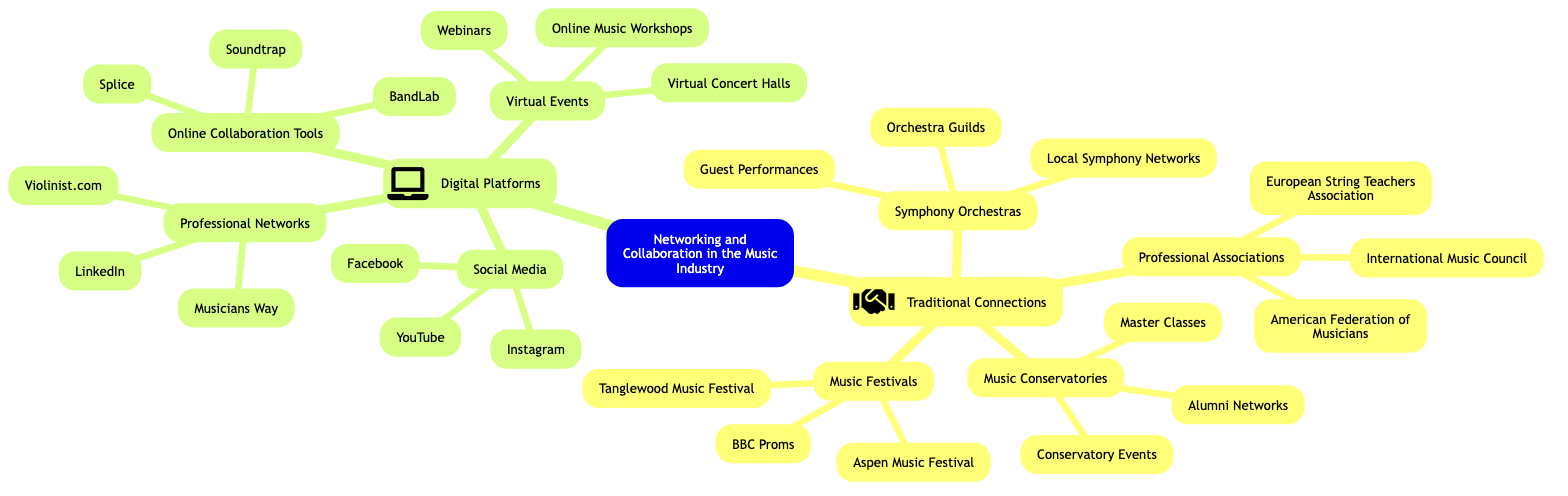What are the four main subtopics in the diagram? The diagram branches into two main categories: Traditional Connections and Digital Platforms. Under each category, there are more subtopics. Counting these, we see there are four subtopics under Traditional Connections (Symphony Orchestras, Music Conservatories, Professional Associations, Music Festivals) and four under Digital Platforms (Social Media, Professional Networks, Online Collaboration Tools, Virtual Events), making a total of eight.
Answer: eight Which branch includes Alumni Networks? Alumni Networks is specifically listed under the branch of Music Conservatories. By checking the subtopic "Traditional Connections," I find that Alumni Networks is one of its elements.
Answer: Music Conservatories What is one example of a Virtual Event? Referring to the subtopic “Virtual Events” under Digital Platforms, we find multiple elements listed, one being "Webinars." This can be directly identified as an example of a Virtual Event in the diagram.
Answer: Webinars How many elements are listed under Online Collaboration Tools? Under the branch "Online Collaboration Tools," there are three elements stated: "Soundtrap," "Splice," and "BandLab." By counting these elements listed, we find that there are three total.
Answer: three Which type of connection is represented by the American Federation of Musicians? The American Federation of Musicians is categorized under Professional Associations, which is part of the Traditional Connections subtopic. It indicates a form of professional networking that is traditional in the music industry.
Answer: Professional Associations What digital platform is focused on professional networking? The Professional Networks subtopic specifically addresses digital platforms aimed at professional connections. The diagram mentions LinkedIn, Violinist.com, and Musicians Way as examples of this type of platform. Hence, one of them would be sufficient as an answer.
Answer: LinkedIn What is the relationship between Music Festivals and Traditional Connections? Music Festivals is a subtopic of Traditional Connections, indicating that it falls under the broader category of networking opportunities within the traditional framework of the music industry. This illustrates how Music Festivals serve as a means to connect musicians and audiences in a traditional sense.
Answer: Traditional Connections Which social media platform is mentioned in the diagram? Inspecting the Social Media branch under Digital Platforms, I find "Instagram," "Facebook," and "YouTube" explicitly listed. Each of these represents a social media platform utilized for networking and collaboration in the music industry. Therefore, any of these would suffice in answering the question.
Answer: Instagram 